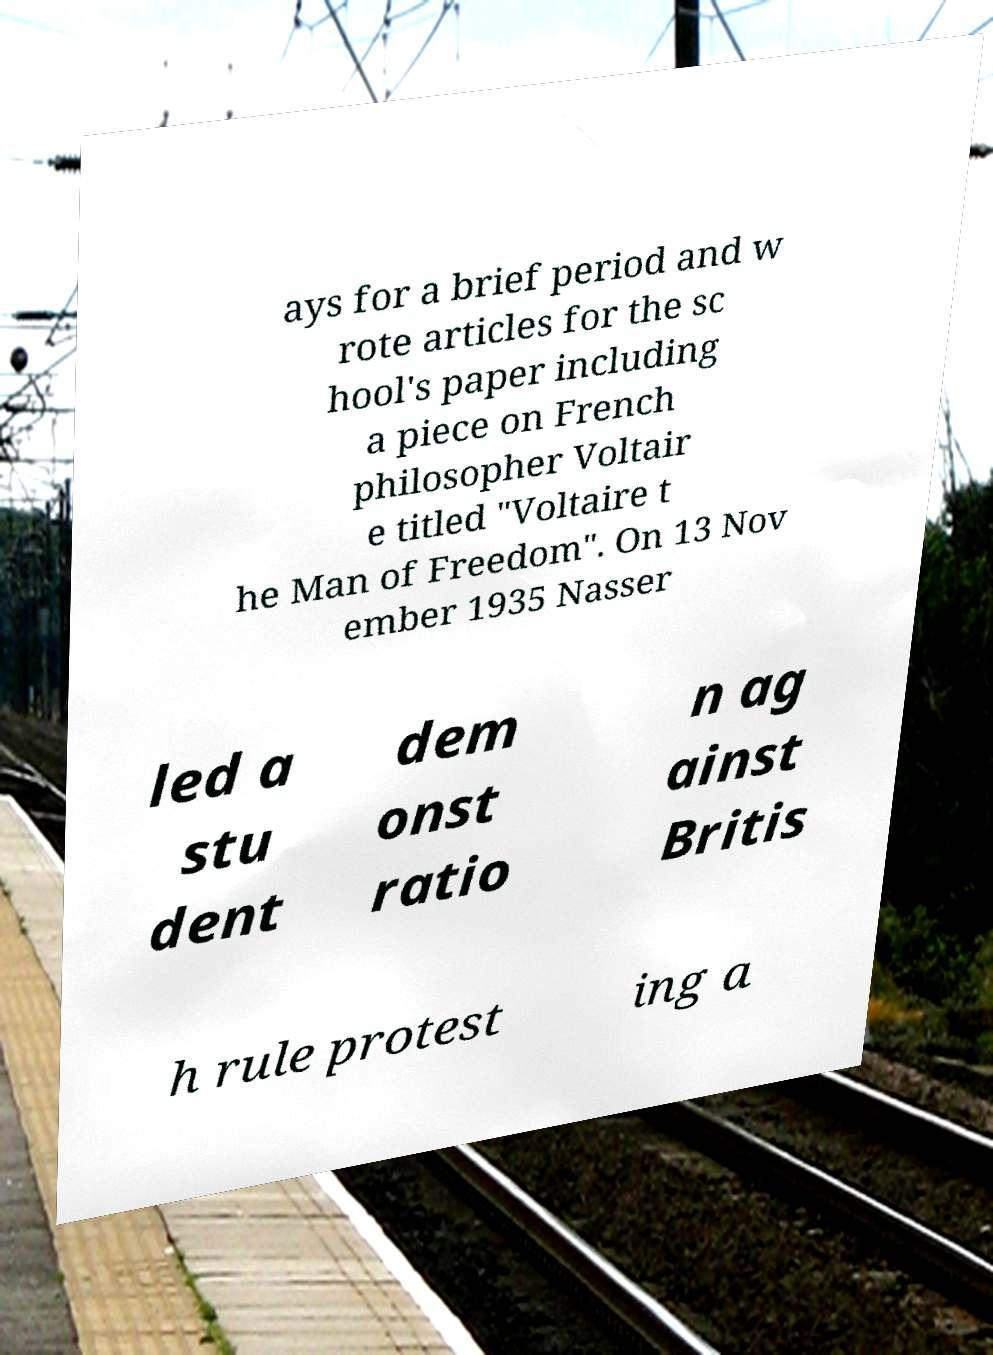Could you extract and type out the text from this image? ays for a brief period and w rote articles for the sc hool's paper including a piece on French philosopher Voltair e titled "Voltaire t he Man of Freedom". On 13 Nov ember 1935 Nasser led a stu dent dem onst ratio n ag ainst Britis h rule protest ing a 